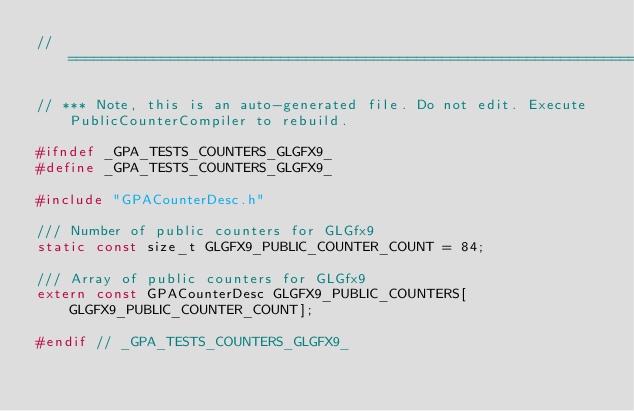Convert code to text. <code><loc_0><loc_0><loc_500><loc_500><_C_>//==============================================================================

// *** Note, this is an auto-generated file. Do not edit. Execute PublicCounterCompiler to rebuild.

#ifndef _GPA_TESTS_COUNTERS_GLGFX9_
#define _GPA_TESTS_COUNTERS_GLGFX9_

#include "GPACounterDesc.h"

/// Number of public counters for GLGfx9
static const size_t GLGFX9_PUBLIC_COUNTER_COUNT = 84;

/// Array of public counters for GLGfx9
extern const GPACounterDesc GLGFX9_PUBLIC_COUNTERS[GLGFX9_PUBLIC_COUNTER_COUNT];

#endif // _GPA_TESTS_COUNTERS_GLGFX9_
</code> 